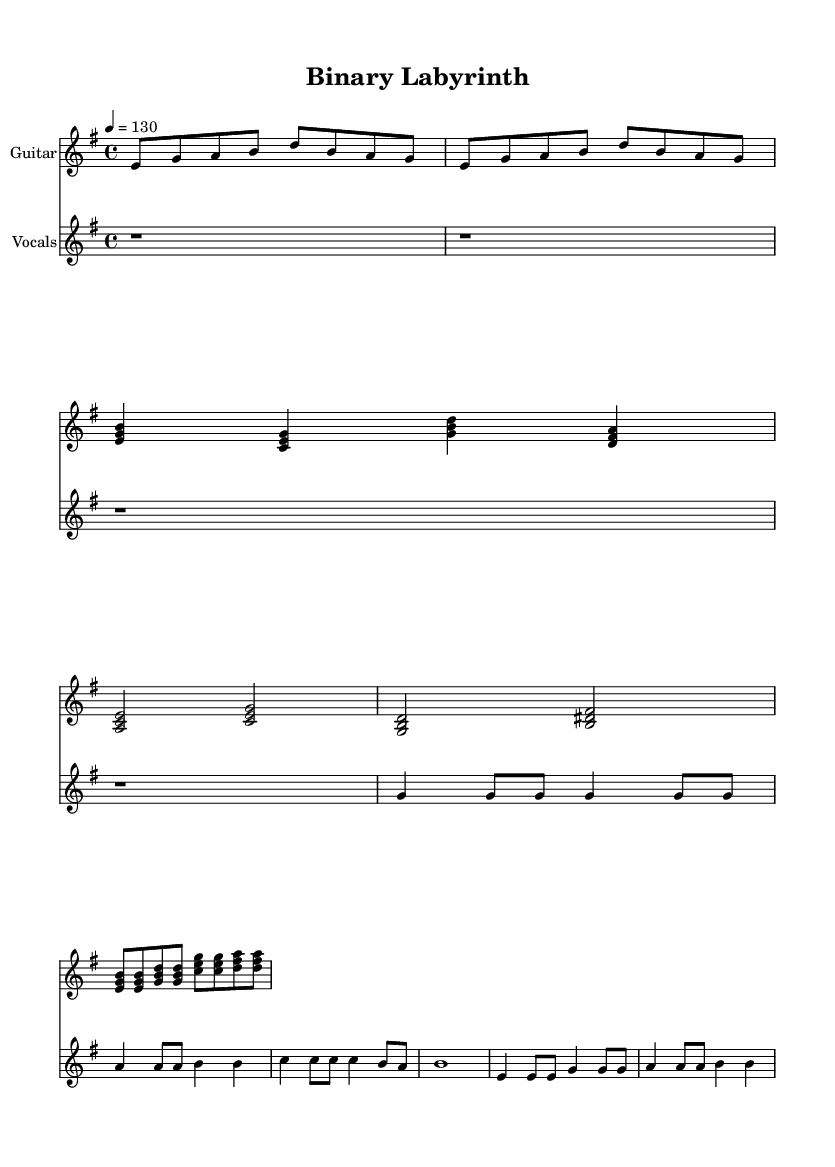What is the key signature of this music? The key signature is E minor, which has one sharp (F#). This can be identified in the part of the score that shows the key signature at the start.
Answer: E minor What is the time signature of this music? The time signature is 4/4, which is indicated at the beginning of the score. It shows that there are four beats in each measure.
Answer: 4/4 What is the tempo marking for this piece? The tempo marking is 4 = 130, meaning that the quarter note is set at a speed of 130 beats per minute. This can be found in the tempo indication at the start of the score.
Answer: 130 How many measures are in the guitar riff? There are two measures in the guitar riff, as indicated by the presence of two repeating phrases in the notation. Each phrase corresponds to one measure.
Answer: 2 What type of chords are predominantly used in the guitar verse? The guitar verse predominantly utilizes triads, indicated by the three-note chords that are played throughout the section, characteristic of rock music.
Answer: Triads In the chorus, what is the rhythmic pattern followed? The rhythmic pattern in the chorus consists of eight notes played in a consistent pattern of eighth notes across the measures, providing a driving rock feel.
Answer: Eighth notes What is the lyrical theme of this piece? The lyrical theme revolves around navigating complex systems and algorithms, as evidenced by the lyrics provided in the verse. The words reference 'navigating' and 'algorithms'.
Answer: Algorithms 